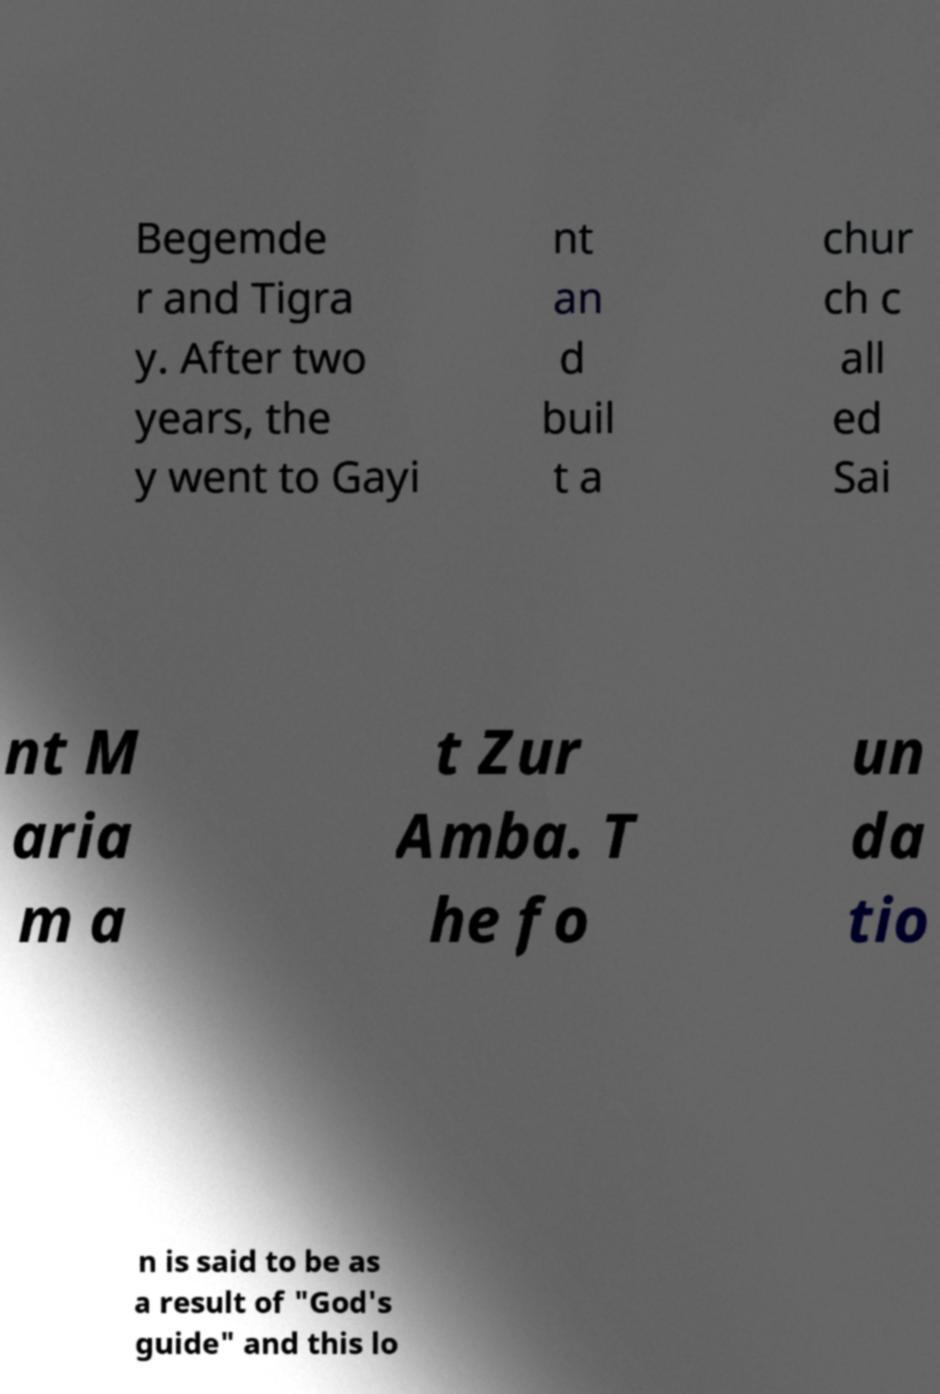There's text embedded in this image that I need extracted. Can you transcribe it verbatim? Begemde r and Tigra y. After two years, the y went to Gayi nt an d buil t a chur ch c all ed Sai nt M aria m a t Zur Amba. T he fo un da tio n is said to be as a result of "God's guide" and this lo 